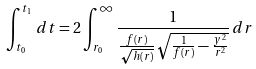<formula> <loc_0><loc_0><loc_500><loc_500>\int _ { t _ { 0 } } ^ { t _ { 1 } } \, d t = 2 \int _ { r _ { 0 } } ^ { \infty } \frac { 1 } { \frac { f ( r ) } { \sqrt { h ( r ) } } \sqrt { \frac { 1 } { f ( r ) } - \frac { y ^ { 2 } } { r ^ { 2 } } } } \, d r</formula> 